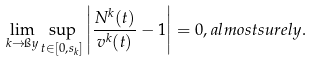Convert formula to latex. <formula><loc_0><loc_0><loc_500><loc_500>\lim _ { k \to \i y } \sup _ { t \in [ 0 , s _ { k } ] } \left | \frac { N ^ { k } ( t ) } { v ^ { k } ( t ) } - 1 \right | = 0 , a l m o s t s u r e l y .</formula> 